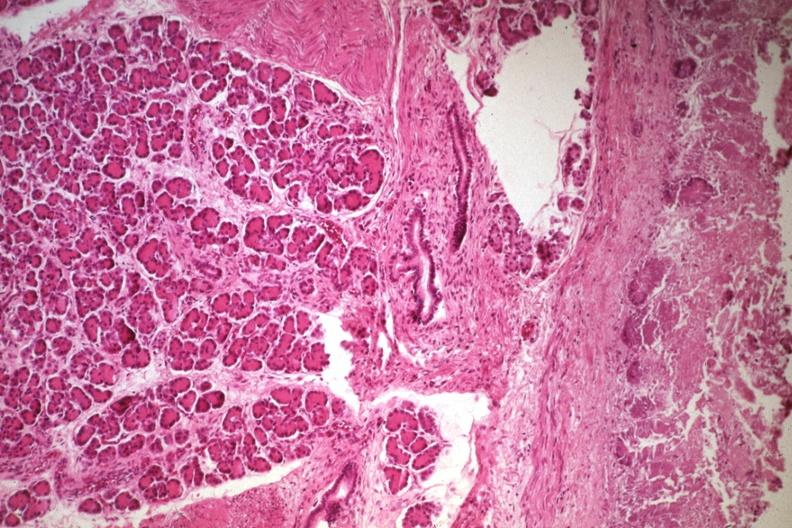what is present?
Answer the question using a single word or phrase. Gastrointestinal 